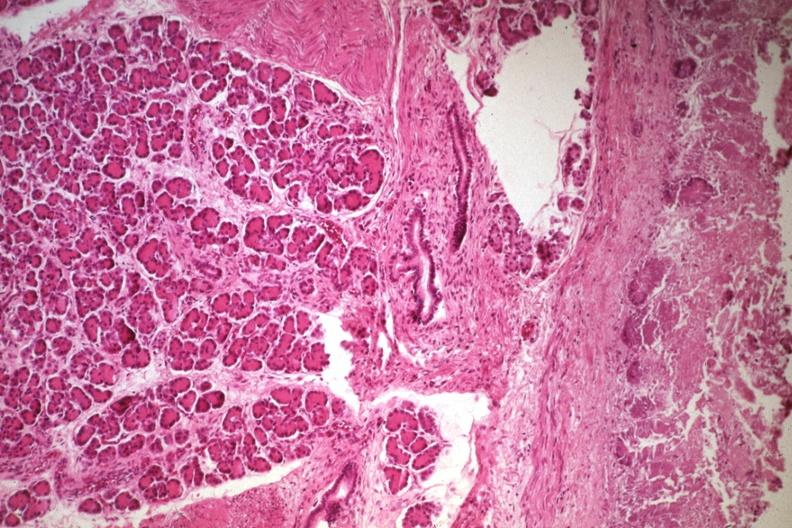what is present?
Answer the question using a single word or phrase. Gastrointestinal 